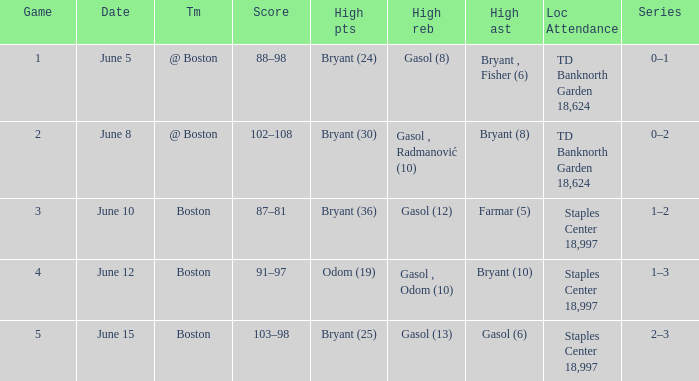Name the number of games on june 12 1.0. 